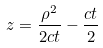<formula> <loc_0><loc_0><loc_500><loc_500>z = \frac { \rho ^ { 2 } } { 2 c t } - \frac { c t } { 2 }</formula> 